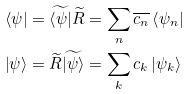Convert formula to latex. <formula><loc_0><loc_0><loc_500><loc_500>\left \langle \psi \right | & = \widetilde { \left \langle \psi \right | } \widetilde { R } = \sum _ { n } \overline { c _ { n } } \left \langle \psi _ { n } \right | \\ \left | \psi \right \rangle & = \widetilde { R } \widetilde { \left | \psi \right \rangle } = \sum _ { k } c _ { k } \left | \psi _ { k } \right \rangle</formula> 